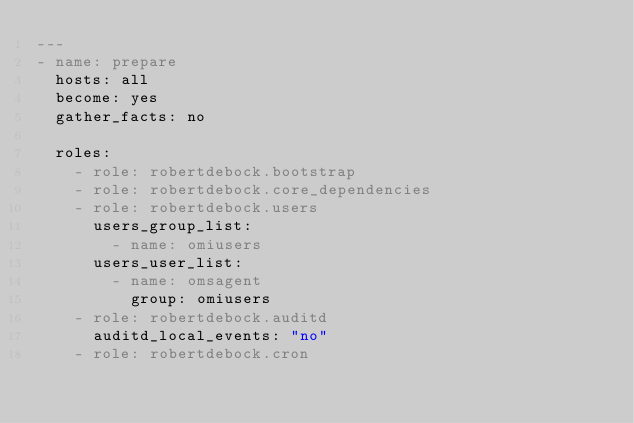Convert code to text. <code><loc_0><loc_0><loc_500><loc_500><_YAML_>---
- name: prepare
  hosts: all
  become: yes
  gather_facts: no

  roles:
    - role: robertdebock.bootstrap
    - role: robertdebock.core_dependencies
    - role: robertdebock.users
      users_group_list:
        - name: omiusers
      users_user_list:
        - name: omsagent
          group: omiusers
    - role: robertdebock.auditd
      auditd_local_events: "no"
    - role: robertdebock.cron
</code> 